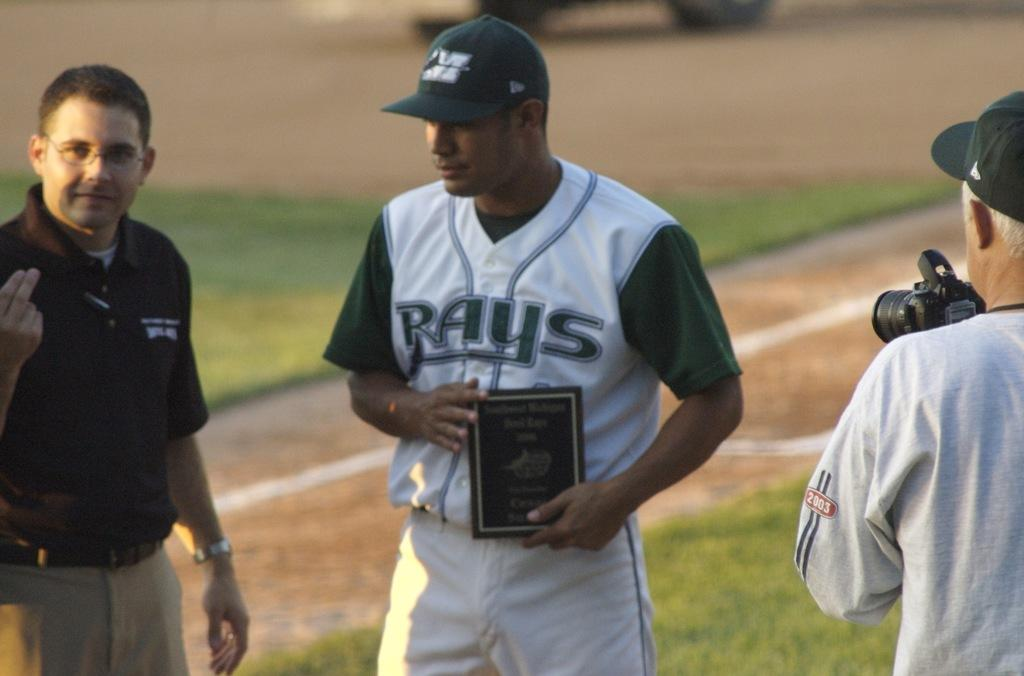<image>
Write a terse but informative summary of the picture. A player from the Rays baseball team is receiving an award. 